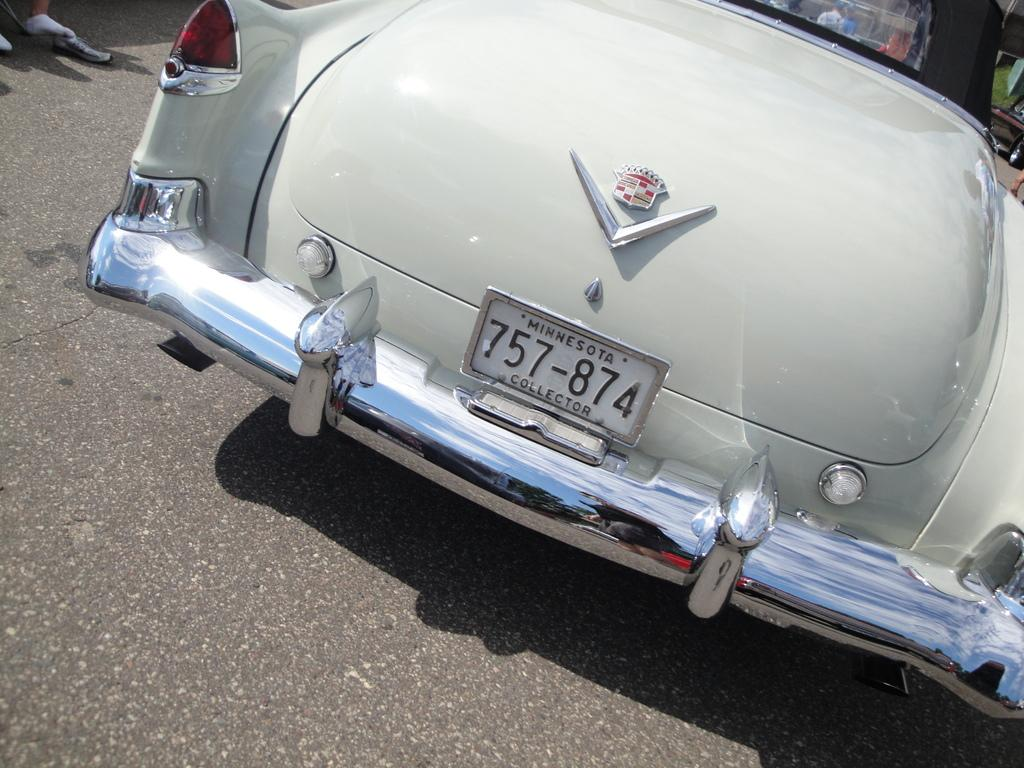What is the main subject of subject of the image? There is a vehicle in the image. Where is the vehicle located? The vehicle is on the road. What type of skin condition can be seen on the vehicle in the image? There is no skin condition present on the vehicle in the image, as vehicles do not have skin. 